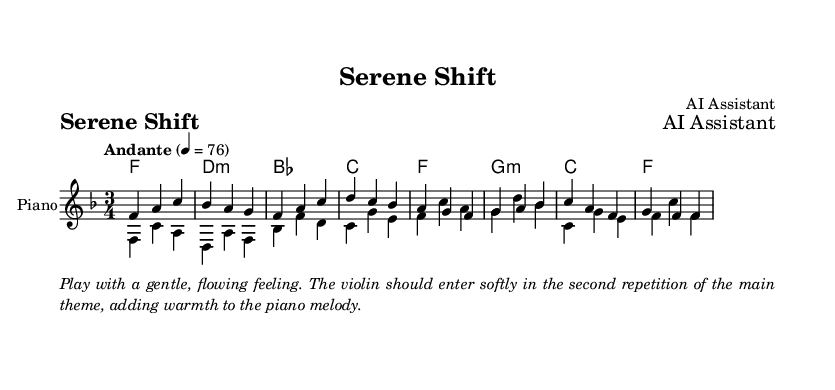What is the key signature of this music? The key signature is indicated by the presence of one flat, which signifies F major.
Answer: F major What is the time signature of this music? The time signature is shown at the beginning of the score, specifying three beats per measure.
Answer: 3/4 What is the tempo marking for this piece? The tempo marking appears in the score indicating a moderately slow pace, set to 76 beats per minute.
Answer: Andante, 76 How many measures are in the melody? By counting the groups separated by vertical lines (bar lines), there are 8 measures in the melody.
Answer: 8 List the first note of the bass line. The bass line starts with the note F, as shown in the first measure of the score.
Answer: F In which voice does the melody appear? The melody is written in the first voice on the score, designated for the piano part.
Answer: Voice one What type of harmony is used in this piece? The harmony combines major and minor chords, as indicated by the chord symbols throughout the score.
Answer: Major and minor chords 